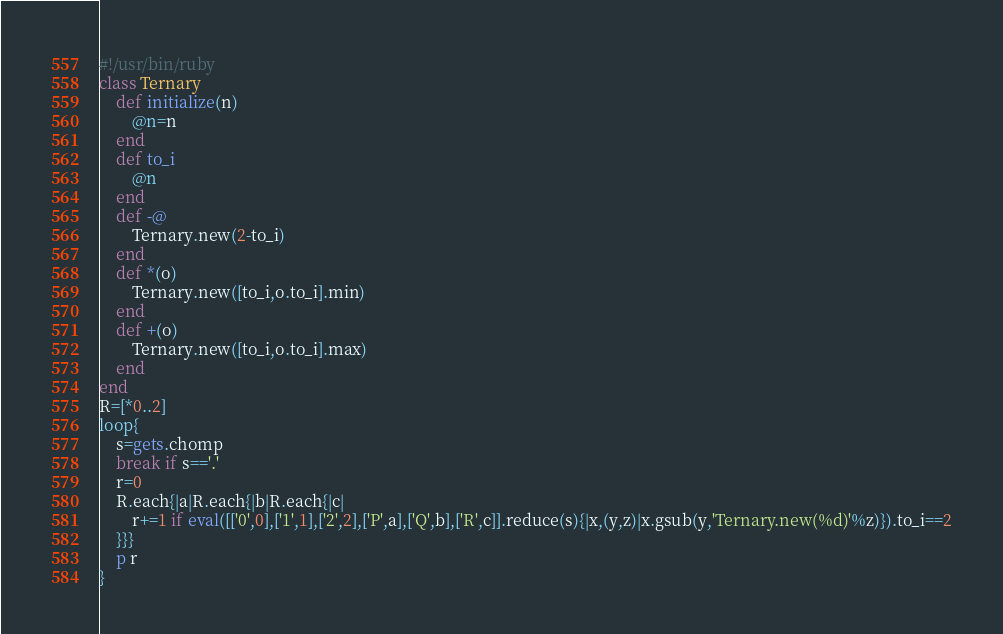<code> <loc_0><loc_0><loc_500><loc_500><_Ruby_>#!/usr/bin/ruby
class Ternary
	def initialize(n)
		@n=n
	end
	def to_i
		@n
	end
	def -@
		Ternary.new(2-to_i)
	end
	def *(o)
		Ternary.new([to_i,o.to_i].min)
	end
	def +(o)
		Ternary.new([to_i,o.to_i].max)
	end
end
R=[*0..2]
loop{
	s=gets.chomp
	break if s=='.'
	r=0
	R.each{|a|R.each{|b|R.each{|c|
		r+=1 if eval([['0',0],['1',1],['2',2],['P',a],['Q',b],['R',c]].reduce(s){|x,(y,z)|x.gsub(y,'Ternary.new(%d)'%z)}).to_i==2
	}}}
	p r
}

</code> 